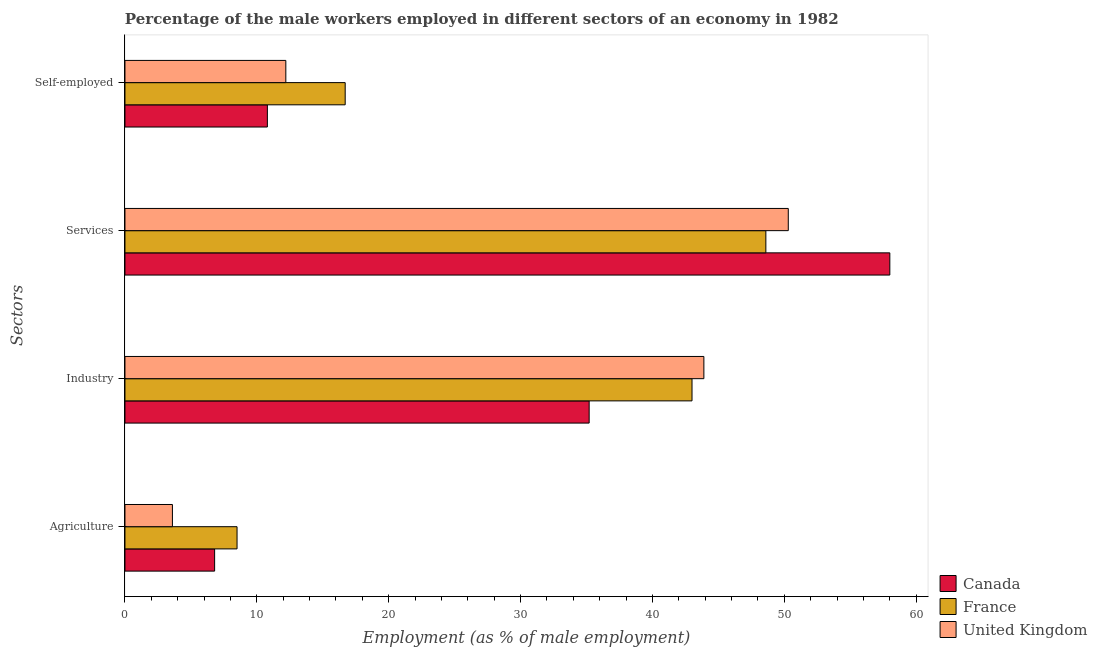How many different coloured bars are there?
Give a very brief answer. 3. Are the number of bars per tick equal to the number of legend labels?
Your answer should be compact. Yes. Are the number of bars on each tick of the Y-axis equal?
Offer a terse response. Yes. How many bars are there on the 4th tick from the top?
Offer a terse response. 3. How many bars are there on the 3rd tick from the bottom?
Your answer should be very brief. 3. What is the label of the 3rd group of bars from the top?
Your answer should be very brief. Industry. What is the percentage of male workers in industry in France?
Ensure brevity in your answer.  43. Across all countries, what is the maximum percentage of male workers in agriculture?
Make the answer very short. 8.5. Across all countries, what is the minimum percentage of male workers in services?
Your response must be concise. 48.6. In which country was the percentage of male workers in agriculture minimum?
Make the answer very short. United Kingdom. What is the total percentage of self employed male workers in the graph?
Give a very brief answer. 39.7. What is the difference between the percentage of male workers in services in Canada and that in United Kingdom?
Give a very brief answer. 7.7. What is the difference between the percentage of male workers in services in Canada and the percentage of male workers in industry in United Kingdom?
Provide a short and direct response. 14.1. What is the average percentage of male workers in services per country?
Your response must be concise. 52.3. What is the difference between the percentage of male workers in agriculture and percentage of male workers in industry in France?
Offer a terse response. -34.5. In how many countries, is the percentage of self employed male workers greater than 18 %?
Give a very brief answer. 0. What is the ratio of the percentage of self employed male workers in Canada to that in United Kingdom?
Your answer should be compact. 0.89. Is the percentage of male workers in agriculture in United Kingdom less than that in France?
Your answer should be compact. Yes. What is the difference between the highest and the second highest percentage of male workers in services?
Provide a short and direct response. 7.7. What is the difference between the highest and the lowest percentage of male workers in industry?
Provide a short and direct response. 8.7. In how many countries, is the percentage of male workers in agriculture greater than the average percentage of male workers in agriculture taken over all countries?
Give a very brief answer. 2. Is the sum of the percentage of male workers in industry in Canada and United Kingdom greater than the maximum percentage of male workers in agriculture across all countries?
Make the answer very short. Yes. What does the 2nd bar from the bottom in Self-employed represents?
Your response must be concise. France. Are all the bars in the graph horizontal?
Provide a short and direct response. Yes. What is the difference between two consecutive major ticks on the X-axis?
Provide a short and direct response. 10. Are the values on the major ticks of X-axis written in scientific E-notation?
Offer a very short reply. No. Does the graph contain any zero values?
Keep it short and to the point. No. Where does the legend appear in the graph?
Provide a succinct answer. Bottom right. How many legend labels are there?
Ensure brevity in your answer.  3. How are the legend labels stacked?
Your response must be concise. Vertical. What is the title of the graph?
Your answer should be compact. Percentage of the male workers employed in different sectors of an economy in 1982. Does "Bhutan" appear as one of the legend labels in the graph?
Your response must be concise. No. What is the label or title of the X-axis?
Give a very brief answer. Employment (as % of male employment). What is the label or title of the Y-axis?
Give a very brief answer. Sectors. What is the Employment (as % of male employment) of Canada in Agriculture?
Offer a very short reply. 6.8. What is the Employment (as % of male employment) of France in Agriculture?
Offer a terse response. 8.5. What is the Employment (as % of male employment) of United Kingdom in Agriculture?
Provide a short and direct response. 3.6. What is the Employment (as % of male employment) in Canada in Industry?
Your response must be concise. 35.2. What is the Employment (as % of male employment) of France in Industry?
Provide a succinct answer. 43. What is the Employment (as % of male employment) in United Kingdom in Industry?
Your answer should be compact. 43.9. What is the Employment (as % of male employment) of Canada in Services?
Give a very brief answer. 58. What is the Employment (as % of male employment) of France in Services?
Provide a succinct answer. 48.6. What is the Employment (as % of male employment) of United Kingdom in Services?
Ensure brevity in your answer.  50.3. What is the Employment (as % of male employment) in Canada in Self-employed?
Your answer should be very brief. 10.8. What is the Employment (as % of male employment) in France in Self-employed?
Provide a succinct answer. 16.7. What is the Employment (as % of male employment) of United Kingdom in Self-employed?
Provide a succinct answer. 12.2. Across all Sectors, what is the maximum Employment (as % of male employment) of France?
Make the answer very short. 48.6. Across all Sectors, what is the maximum Employment (as % of male employment) of United Kingdom?
Offer a very short reply. 50.3. Across all Sectors, what is the minimum Employment (as % of male employment) in Canada?
Your response must be concise. 6.8. Across all Sectors, what is the minimum Employment (as % of male employment) of France?
Provide a succinct answer. 8.5. Across all Sectors, what is the minimum Employment (as % of male employment) of United Kingdom?
Provide a short and direct response. 3.6. What is the total Employment (as % of male employment) of Canada in the graph?
Your answer should be compact. 110.8. What is the total Employment (as % of male employment) in France in the graph?
Offer a very short reply. 116.8. What is the total Employment (as % of male employment) in United Kingdom in the graph?
Give a very brief answer. 110. What is the difference between the Employment (as % of male employment) of Canada in Agriculture and that in Industry?
Offer a terse response. -28.4. What is the difference between the Employment (as % of male employment) in France in Agriculture and that in Industry?
Provide a short and direct response. -34.5. What is the difference between the Employment (as % of male employment) of United Kingdom in Agriculture and that in Industry?
Your response must be concise. -40.3. What is the difference between the Employment (as % of male employment) in Canada in Agriculture and that in Services?
Make the answer very short. -51.2. What is the difference between the Employment (as % of male employment) of France in Agriculture and that in Services?
Provide a short and direct response. -40.1. What is the difference between the Employment (as % of male employment) in United Kingdom in Agriculture and that in Services?
Make the answer very short. -46.7. What is the difference between the Employment (as % of male employment) of France in Agriculture and that in Self-employed?
Provide a succinct answer. -8.2. What is the difference between the Employment (as % of male employment) of Canada in Industry and that in Services?
Provide a succinct answer. -22.8. What is the difference between the Employment (as % of male employment) of United Kingdom in Industry and that in Services?
Ensure brevity in your answer.  -6.4. What is the difference between the Employment (as % of male employment) in Canada in Industry and that in Self-employed?
Provide a succinct answer. 24.4. What is the difference between the Employment (as % of male employment) in France in Industry and that in Self-employed?
Offer a terse response. 26.3. What is the difference between the Employment (as % of male employment) in United Kingdom in Industry and that in Self-employed?
Give a very brief answer. 31.7. What is the difference between the Employment (as % of male employment) in Canada in Services and that in Self-employed?
Make the answer very short. 47.2. What is the difference between the Employment (as % of male employment) of France in Services and that in Self-employed?
Ensure brevity in your answer.  31.9. What is the difference between the Employment (as % of male employment) in United Kingdom in Services and that in Self-employed?
Make the answer very short. 38.1. What is the difference between the Employment (as % of male employment) of Canada in Agriculture and the Employment (as % of male employment) of France in Industry?
Your response must be concise. -36.2. What is the difference between the Employment (as % of male employment) in Canada in Agriculture and the Employment (as % of male employment) in United Kingdom in Industry?
Make the answer very short. -37.1. What is the difference between the Employment (as % of male employment) in France in Agriculture and the Employment (as % of male employment) in United Kingdom in Industry?
Ensure brevity in your answer.  -35.4. What is the difference between the Employment (as % of male employment) of Canada in Agriculture and the Employment (as % of male employment) of France in Services?
Offer a very short reply. -41.8. What is the difference between the Employment (as % of male employment) in Canada in Agriculture and the Employment (as % of male employment) in United Kingdom in Services?
Your response must be concise. -43.5. What is the difference between the Employment (as % of male employment) of France in Agriculture and the Employment (as % of male employment) of United Kingdom in Services?
Give a very brief answer. -41.8. What is the difference between the Employment (as % of male employment) of Canada in Agriculture and the Employment (as % of male employment) of United Kingdom in Self-employed?
Offer a terse response. -5.4. What is the difference between the Employment (as % of male employment) of Canada in Industry and the Employment (as % of male employment) of United Kingdom in Services?
Give a very brief answer. -15.1. What is the difference between the Employment (as % of male employment) in France in Industry and the Employment (as % of male employment) in United Kingdom in Self-employed?
Your answer should be very brief. 30.8. What is the difference between the Employment (as % of male employment) in Canada in Services and the Employment (as % of male employment) in France in Self-employed?
Your answer should be compact. 41.3. What is the difference between the Employment (as % of male employment) of Canada in Services and the Employment (as % of male employment) of United Kingdom in Self-employed?
Your answer should be compact. 45.8. What is the difference between the Employment (as % of male employment) in France in Services and the Employment (as % of male employment) in United Kingdom in Self-employed?
Give a very brief answer. 36.4. What is the average Employment (as % of male employment) in Canada per Sectors?
Make the answer very short. 27.7. What is the average Employment (as % of male employment) of France per Sectors?
Your answer should be very brief. 29.2. What is the average Employment (as % of male employment) of United Kingdom per Sectors?
Keep it short and to the point. 27.5. What is the difference between the Employment (as % of male employment) of Canada and Employment (as % of male employment) of France in Agriculture?
Make the answer very short. -1.7. What is the difference between the Employment (as % of male employment) in France and Employment (as % of male employment) in United Kingdom in Agriculture?
Give a very brief answer. 4.9. What is the difference between the Employment (as % of male employment) in Canada and Employment (as % of male employment) in France in Industry?
Offer a very short reply. -7.8. What is the difference between the Employment (as % of male employment) of Canada and Employment (as % of male employment) of United Kingdom in Industry?
Keep it short and to the point. -8.7. What is the difference between the Employment (as % of male employment) in Canada and Employment (as % of male employment) in France in Services?
Provide a succinct answer. 9.4. What is the difference between the Employment (as % of male employment) in Canada and Employment (as % of male employment) in United Kingdom in Services?
Make the answer very short. 7.7. What is the ratio of the Employment (as % of male employment) in Canada in Agriculture to that in Industry?
Offer a very short reply. 0.19. What is the ratio of the Employment (as % of male employment) of France in Agriculture to that in Industry?
Keep it short and to the point. 0.2. What is the ratio of the Employment (as % of male employment) in United Kingdom in Agriculture to that in Industry?
Offer a very short reply. 0.08. What is the ratio of the Employment (as % of male employment) of Canada in Agriculture to that in Services?
Give a very brief answer. 0.12. What is the ratio of the Employment (as % of male employment) of France in Agriculture to that in Services?
Make the answer very short. 0.17. What is the ratio of the Employment (as % of male employment) in United Kingdom in Agriculture to that in Services?
Give a very brief answer. 0.07. What is the ratio of the Employment (as % of male employment) of Canada in Agriculture to that in Self-employed?
Ensure brevity in your answer.  0.63. What is the ratio of the Employment (as % of male employment) of France in Agriculture to that in Self-employed?
Provide a succinct answer. 0.51. What is the ratio of the Employment (as % of male employment) in United Kingdom in Agriculture to that in Self-employed?
Offer a very short reply. 0.3. What is the ratio of the Employment (as % of male employment) of Canada in Industry to that in Services?
Provide a succinct answer. 0.61. What is the ratio of the Employment (as % of male employment) of France in Industry to that in Services?
Ensure brevity in your answer.  0.88. What is the ratio of the Employment (as % of male employment) of United Kingdom in Industry to that in Services?
Offer a very short reply. 0.87. What is the ratio of the Employment (as % of male employment) of Canada in Industry to that in Self-employed?
Your response must be concise. 3.26. What is the ratio of the Employment (as % of male employment) in France in Industry to that in Self-employed?
Give a very brief answer. 2.57. What is the ratio of the Employment (as % of male employment) of United Kingdom in Industry to that in Self-employed?
Your answer should be very brief. 3.6. What is the ratio of the Employment (as % of male employment) of Canada in Services to that in Self-employed?
Make the answer very short. 5.37. What is the ratio of the Employment (as % of male employment) of France in Services to that in Self-employed?
Offer a very short reply. 2.91. What is the ratio of the Employment (as % of male employment) in United Kingdom in Services to that in Self-employed?
Your answer should be compact. 4.12. What is the difference between the highest and the second highest Employment (as % of male employment) of Canada?
Offer a terse response. 22.8. What is the difference between the highest and the lowest Employment (as % of male employment) of Canada?
Offer a terse response. 51.2. What is the difference between the highest and the lowest Employment (as % of male employment) of France?
Your answer should be very brief. 40.1. What is the difference between the highest and the lowest Employment (as % of male employment) in United Kingdom?
Your response must be concise. 46.7. 